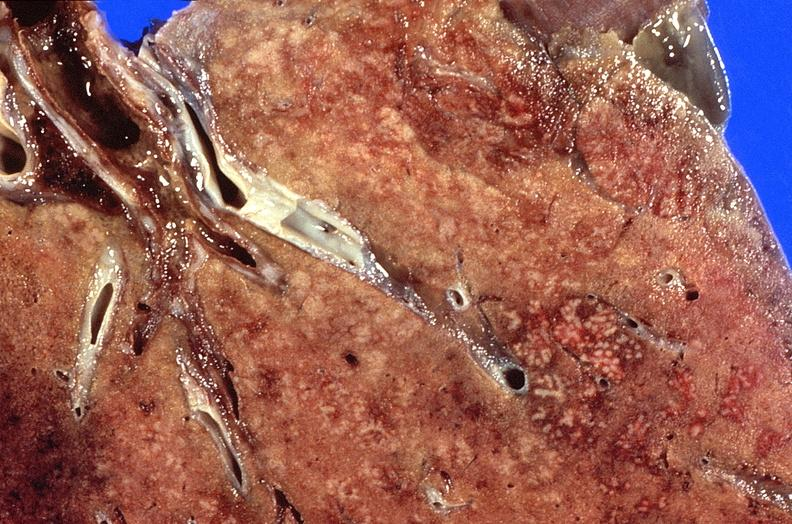s respiratory present?
Answer the question using a single word or phrase. Yes 